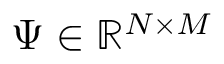<formula> <loc_0><loc_0><loc_500><loc_500>\Psi \in \mathbb { R } ^ { N \times M }</formula> 